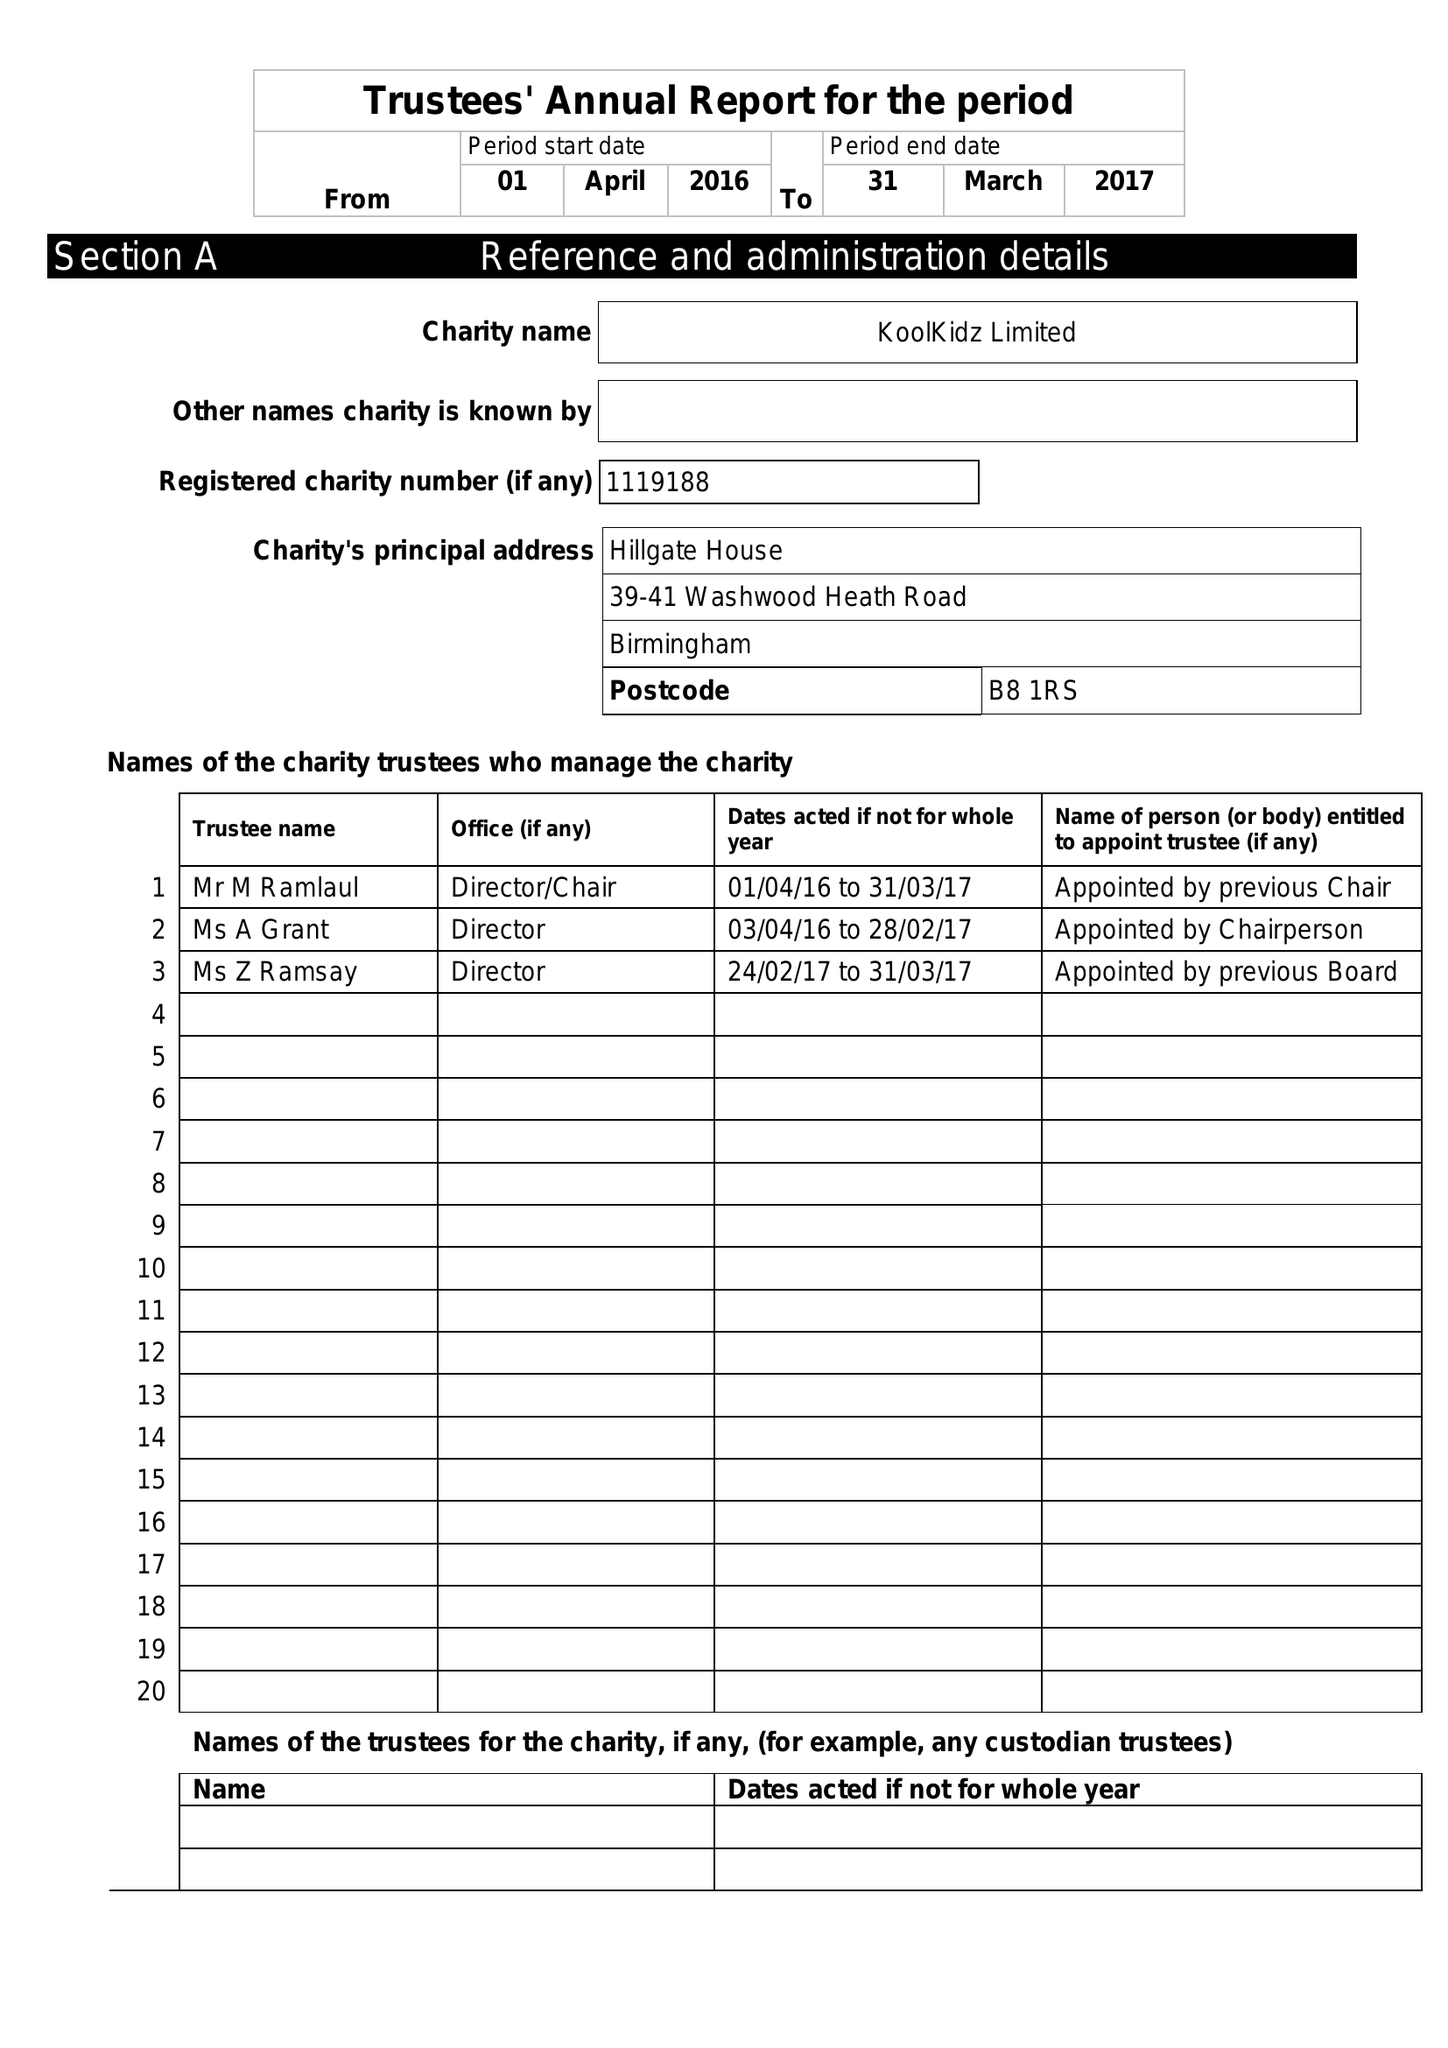What is the value for the income_annually_in_british_pounds?
Answer the question using a single word or phrase. 176163.00 